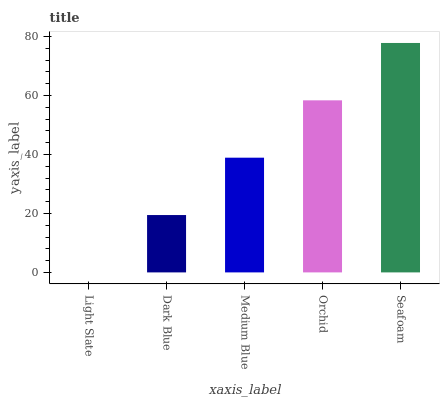Is Light Slate the minimum?
Answer yes or no. Yes. Is Seafoam the maximum?
Answer yes or no. Yes. Is Dark Blue the minimum?
Answer yes or no. No. Is Dark Blue the maximum?
Answer yes or no. No. Is Dark Blue greater than Light Slate?
Answer yes or no. Yes. Is Light Slate less than Dark Blue?
Answer yes or no. Yes. Is Light Slate greater than Dark Blue?
Answer yes or no. No. Is Dark Blue less than Light Slate?
Answer yes or no. No. Is Medium Blue the high median?
Answer yes or no. Yes. Is Medium Blue the low median?
Answer yes or no. Yes. Is Orchid the high median?
Answer yes or no. No. Is Dark Blue the low median?
Answer yes or no. No. 